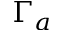Convert formula to latex. <formula><loc_0><loc_0><loc_500><loc_500>\Gamma _ { a }</formula> 